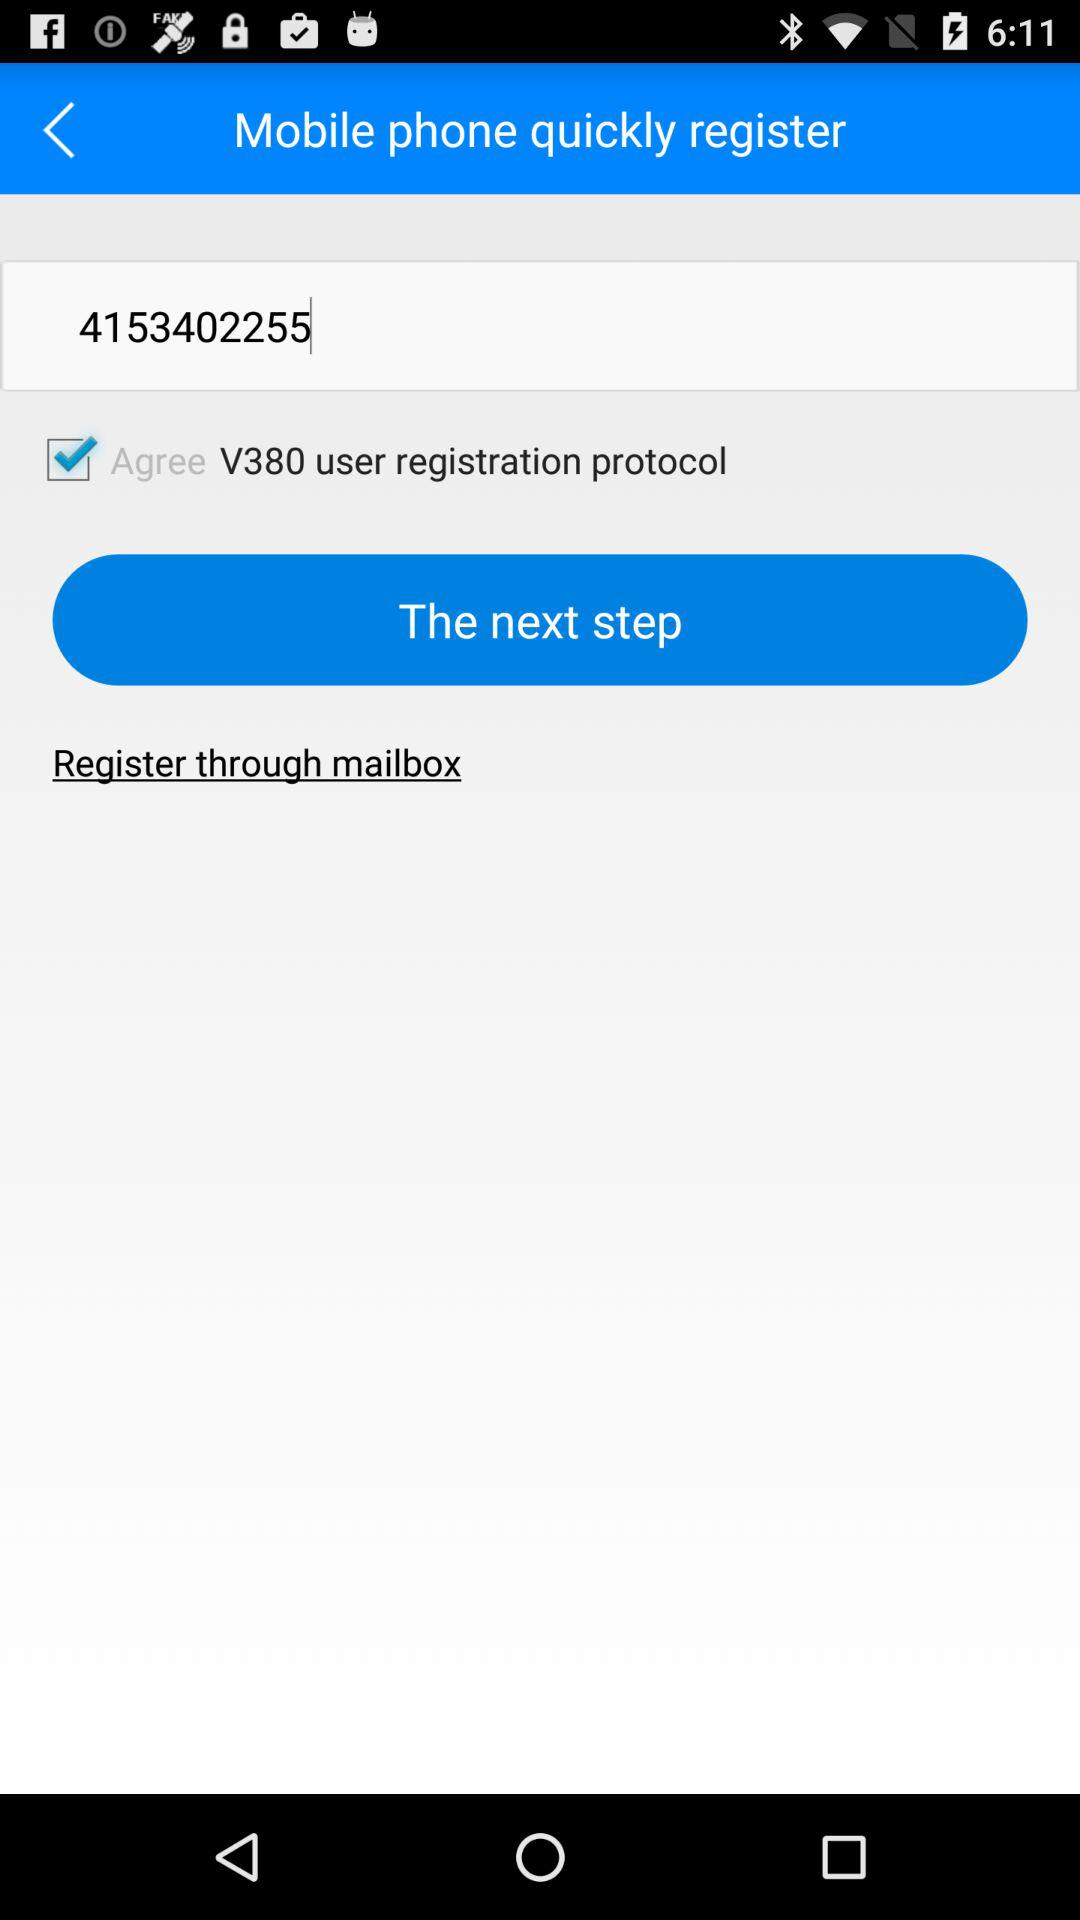What's the phone number? The phone number is 4153402255. 